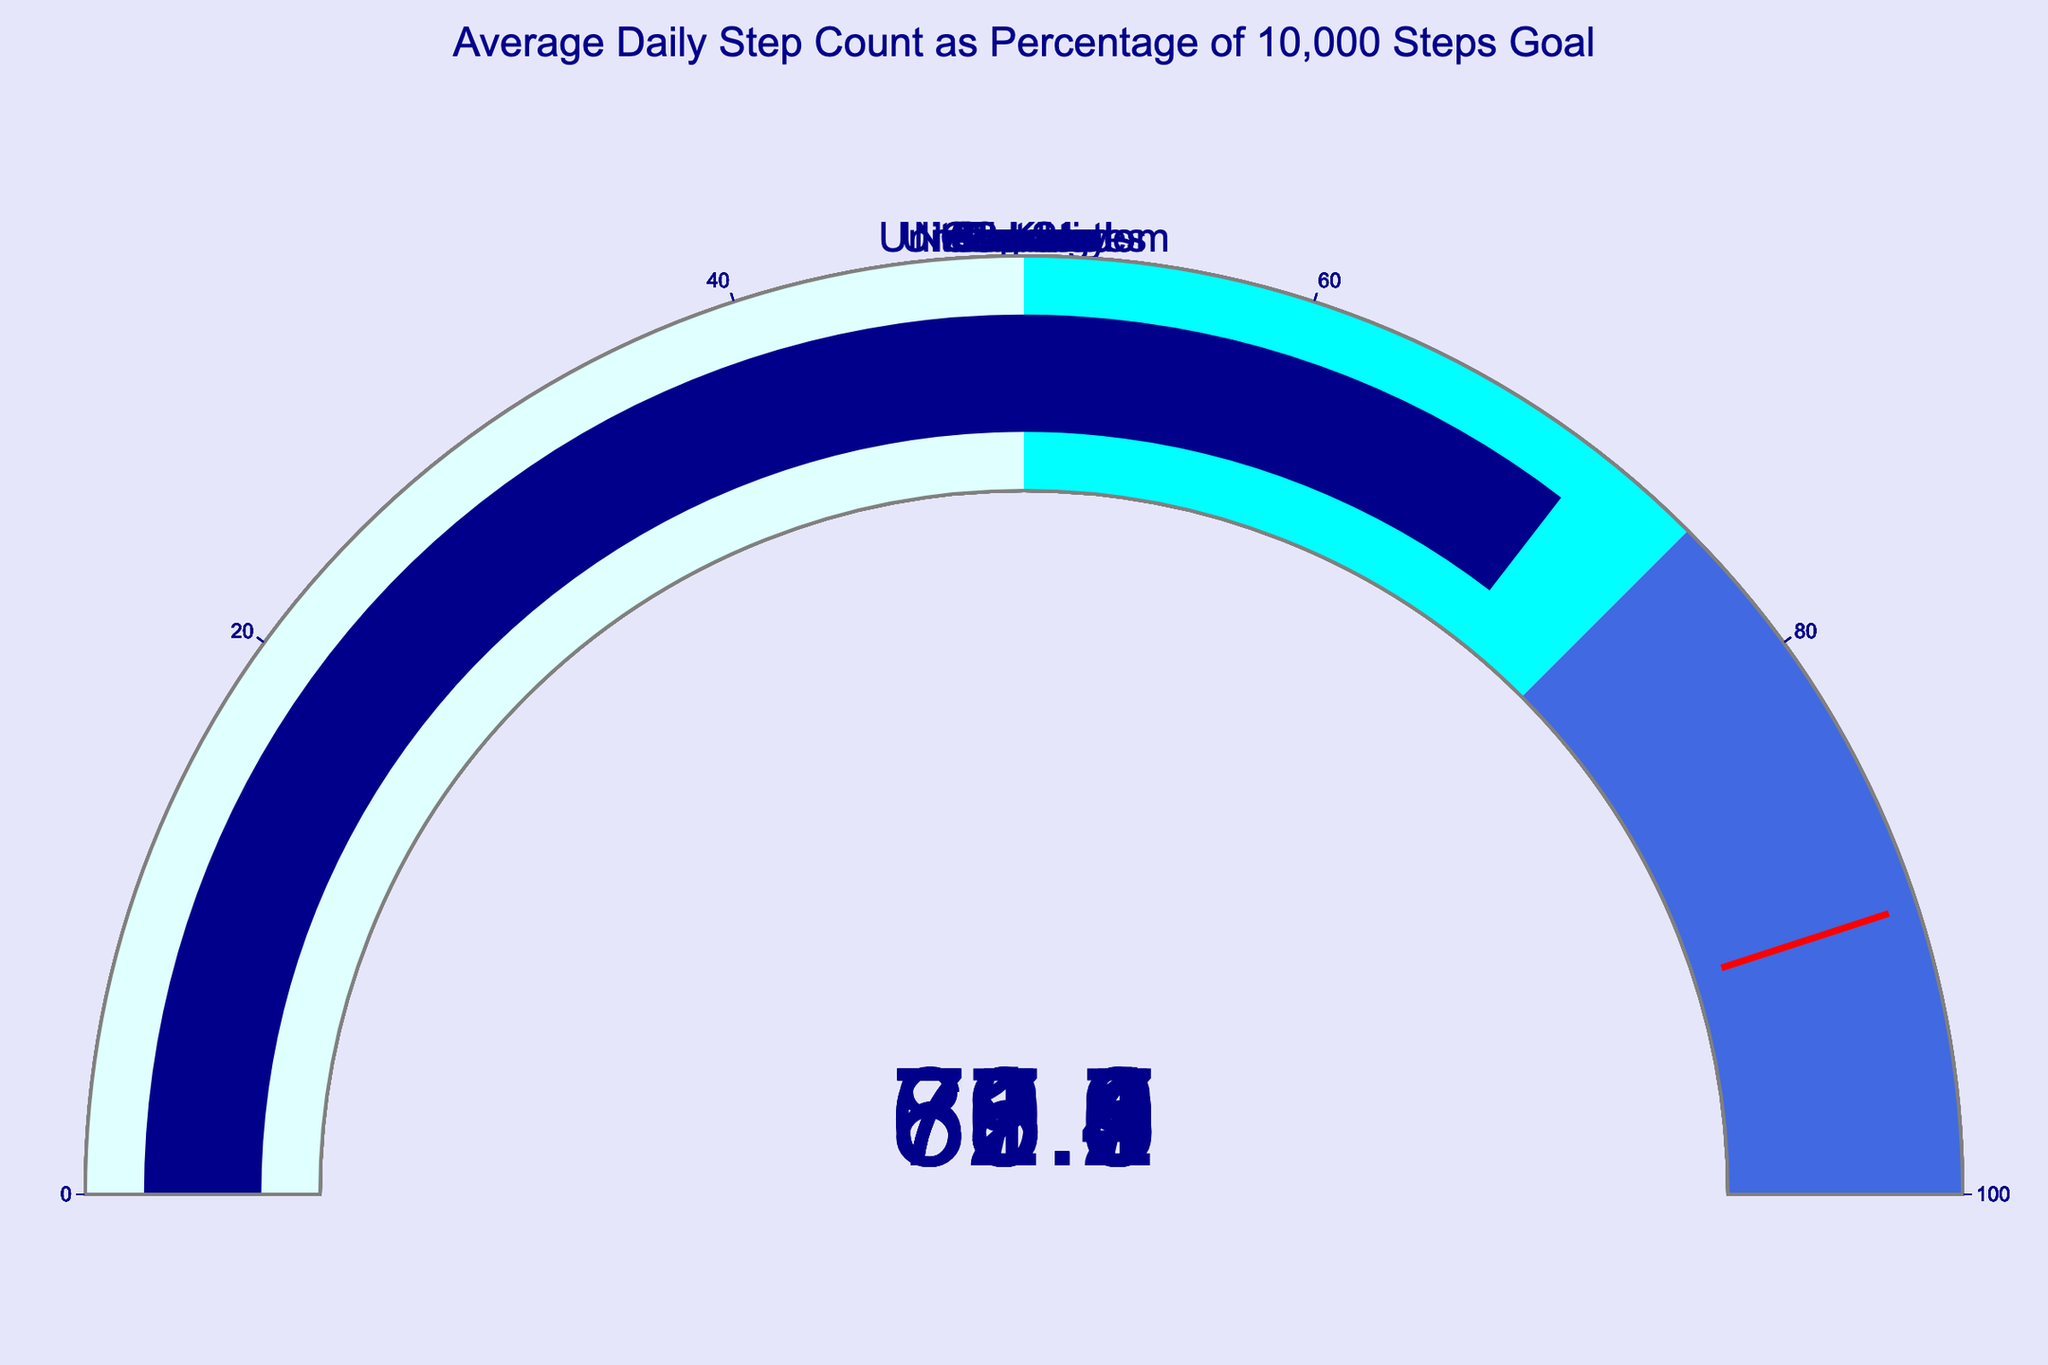What is the average daily step count percentage for Japan? Look at the gauge chart for Japan in the figure and read the indicated value.
Answer: 87.5 How many countries have an average daily step count percentage above 75%? Count the gauges where the value is above 75. The relevant countries are Japan (87.5), Netherlands (79.8), Germany (75.6), and Sweden (82.1).
Answer: 4 Which country has the lowest average daily step count as a percentage of the 10,000 steps goal? Identify the gauge with the lowest value. The United States has the value 62.3%.
Answer: United States By how much does Sweden's average daily step percentage exceed Canada's? Calculate the difference between Sweden's value (82.1) and Canada's value (68.9). 82.1 - 68.9 = 13.2.
Answer: 13.2 What is the median average daily step percentage across all displayed countries? Arrange all percentages in numerical order: 62.3, 65.4, 68.9, 70.9, 71.2, 73.7, 75.6, 79.8, 82.1, 87.5. The median is the average of the 5th and 6th values: (71.2 + 73.7) / 2 = 72.45.
Answer: 72.45 Which country is closest to the top threshold value of 90%? Identify the gauge closest to 90. The closest is Japan at 87.5%.
Answer: Japan Is there any country that exceeds the threshold range (75-90% for blue) but does not reach 90%? Verify if any of the gauges exceed 75 but do not reach 90. Japan (87.5), Netherlands (79.8), Germany (75.6), Sweden (82.1) qualify. These fall in the blue range but do not reach 90.
Answer: Yes Do most of the countries fall within the cyan range (50-75%)? Count the countries with values between 50 and 75. Visual examination shows United States (62.3), Australia (71.2), Canada (68.9), United Kingdom (65.4), France (70.9), Spain (73.7), so 4 out of 10 are in this range. This is not the majority.
Answer: No Which two countries have the closest average daily step percentages, and what is the difference? Find the minimum difference between all pairs. France (70.9) and Australia (71.2) are the closest. The difference is 71.2 - 70.9 = 0.3.
Answer: France and Australia, 0.3 